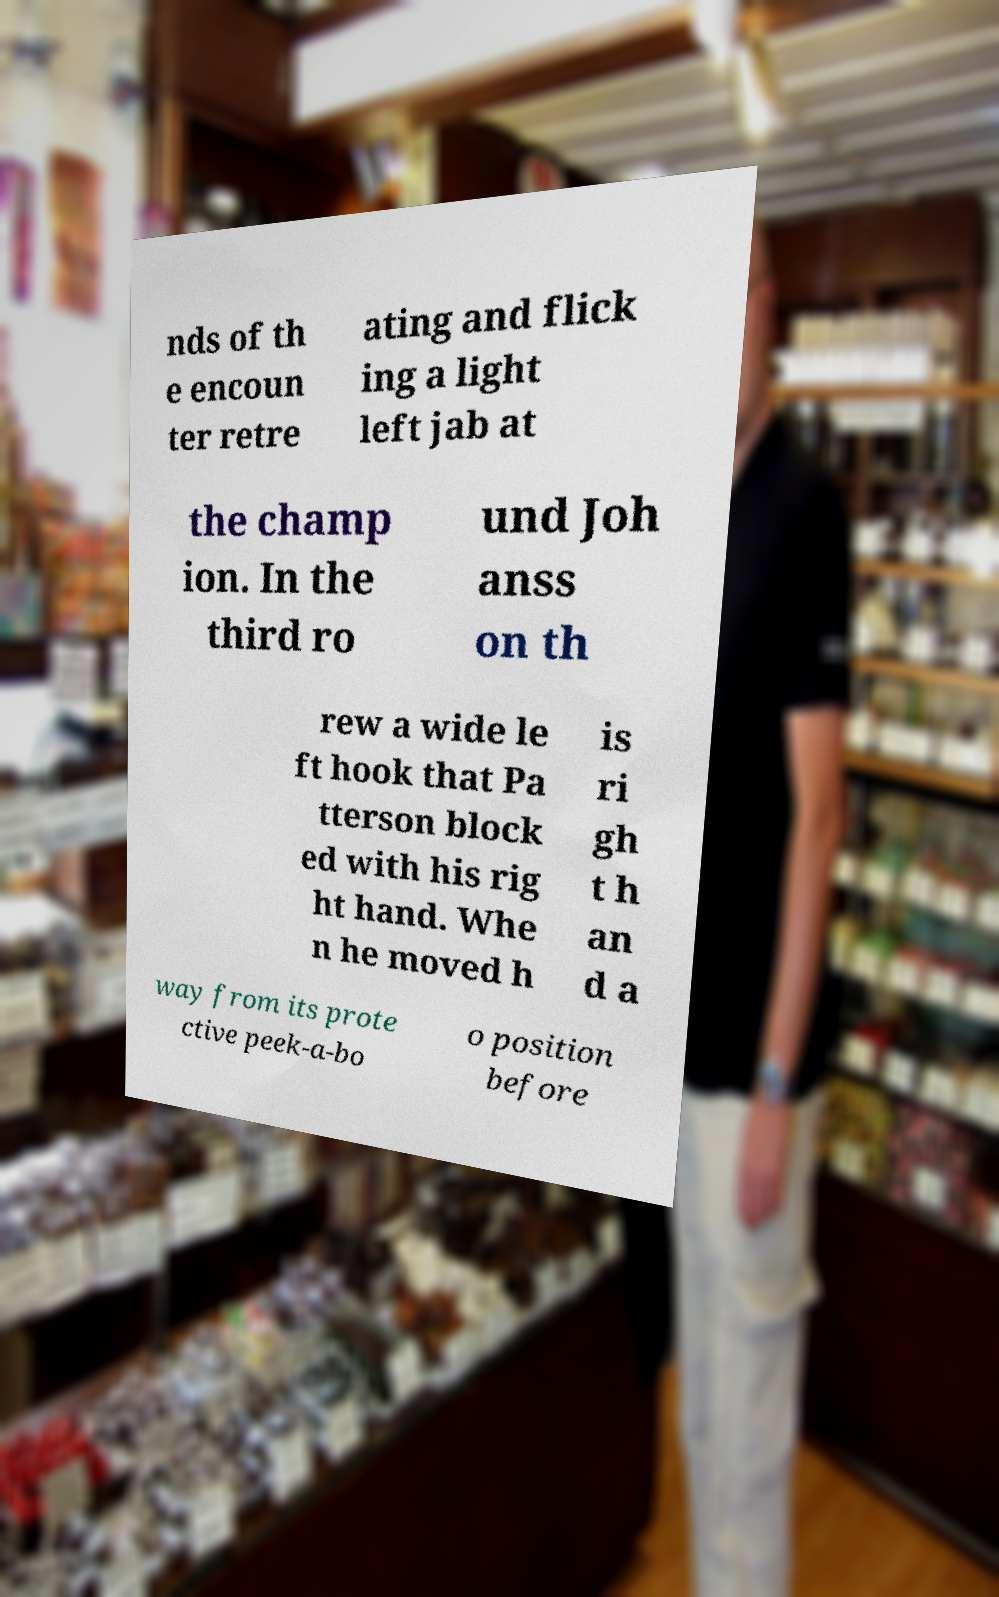Can you accurately transcribe the text from the provided image for me? nds of th e encoun ter retre ating and flick ing a light left jab at the champ ion. In the third ro und Joh anss on th rew a wide le ft hook that Pa tterson block ed with his rig ht hand. Whe n he moved h is ri gh t h an d a way from its prote ctive peek-a-bo o position before 